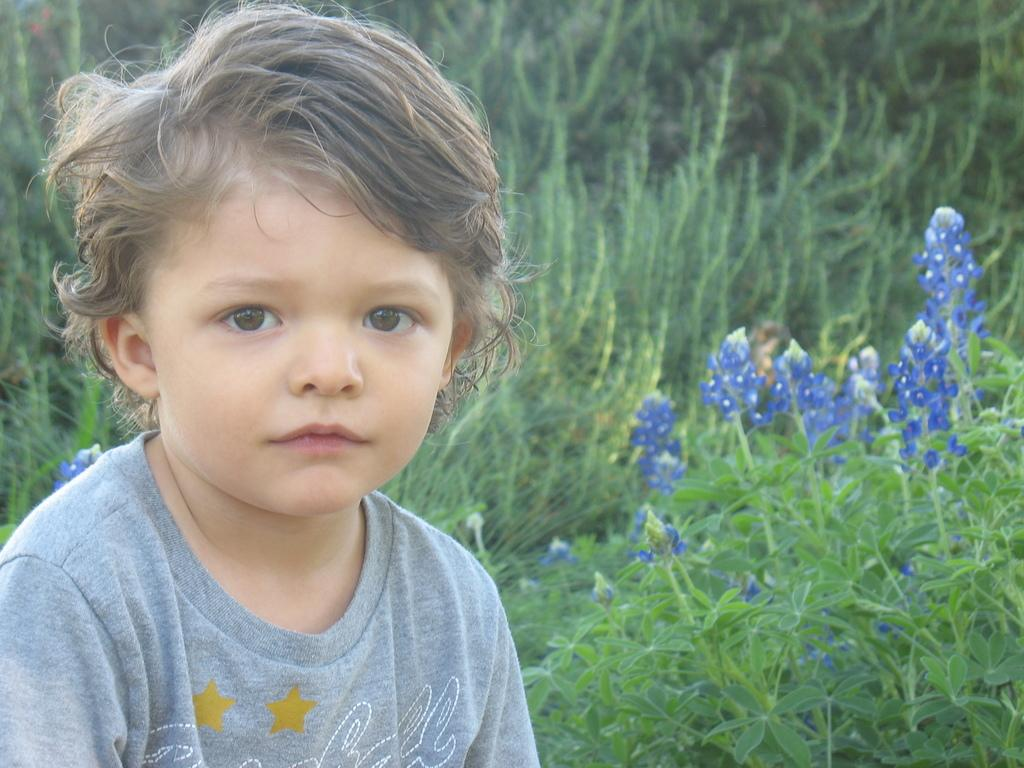Who is the main subject in the image? There is a boy in the image. What is the boy wearing? The boy is wearing a T-shirt. What type of plants can be seen in the image? There are plants with flowers in the image. What color are the flowers? The flowers are blue in color. What can be seen in the background of the image? There are trees visible in the background of the image. What time does the clock in the image show? There is no clock present in the image. How does the boy's memory affect the image? The boy's memory is not visible or relevant in the image. 